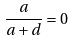Convert formula to latex. <formula><loc_0><loc_0><loc_500><loc_500>\frac { a } { a + d } = 0</formula> 